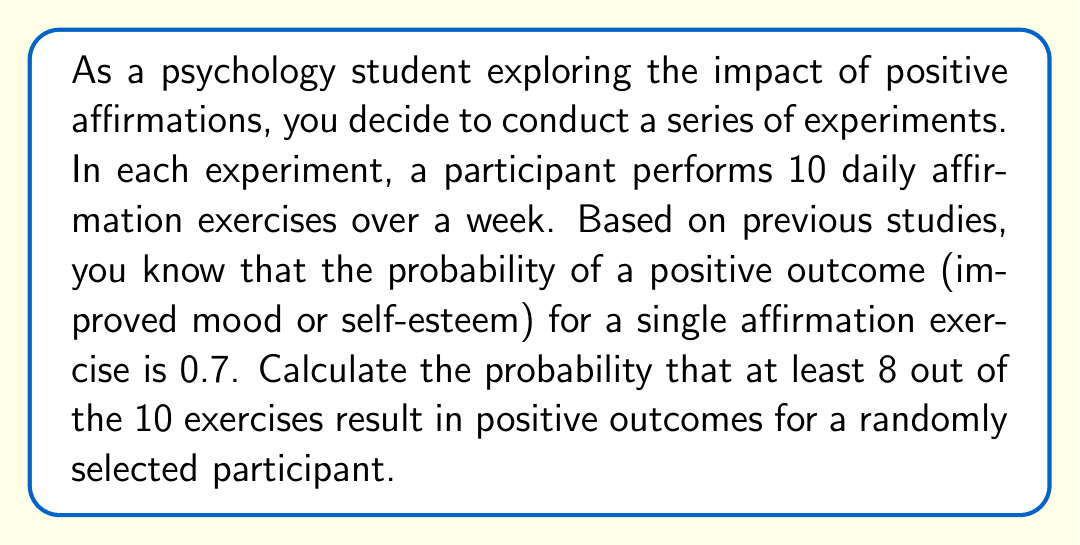Show me your answer to this math problem. To solve this problem, we'll use the binomial probability distribution, as we have a fixed number of independent trials (affirmation exercises) with two possible outcomes (positive or negative) and a constant probability of success.

Let $X$ be the random variable representing the number of positive outcomes in 10 affirmation exercises.

Given:
- Number of trials, $n = 10$
- Probability of success (positive outcome) for each trial, $p = 0.7$
- We want at least 8 successes, so we need to calculate $P(X \geq 8)$

The binomial probability formula is:

$$P(X = k) = \binom{n}{k} p^k (1-p)^{n-k}$$

Where $\binom{n}{k}$ is the binomial coefficient.

We need to calculate $P(X = 8) + P(X = 9) + P(X = 10)$:

1. For 8 successes:
   $$P(X = 8) = \binom{10}{8} (0.7)^8 (0.3)^2 = 45 \times 0.05764801 \times 0.09 = 0.2334045$$

2. For 9 successes:
   $$P(X = 9) = \binom{10}{9} (0.7)^9 (0.3)^1 = 10 \times 0.04035361 \times 0.3 = 0.1210608$$

3. For 10 successes:
   $$P(X = 10) = \binom{10}{10} (0.7)^{10} (0.3)^0 = 1 \times 0.02824752 \times 1 = 0.0282475$$

Now, we sum these probabilities:

$$P(X \geq 8) = P(X = 8) + P(X = 9) + P(X = 10)$$
$$P(X \geq 8) = 0.2334045 + 0.1210608 + 0.0282475 = 0.3827128$$

Therefore, the probability of at least 8 positive outcomes out of 10 affirmation exercises is approximately 0.3827 or 38.27%.
Answer: 0.3827 or 38.27% 